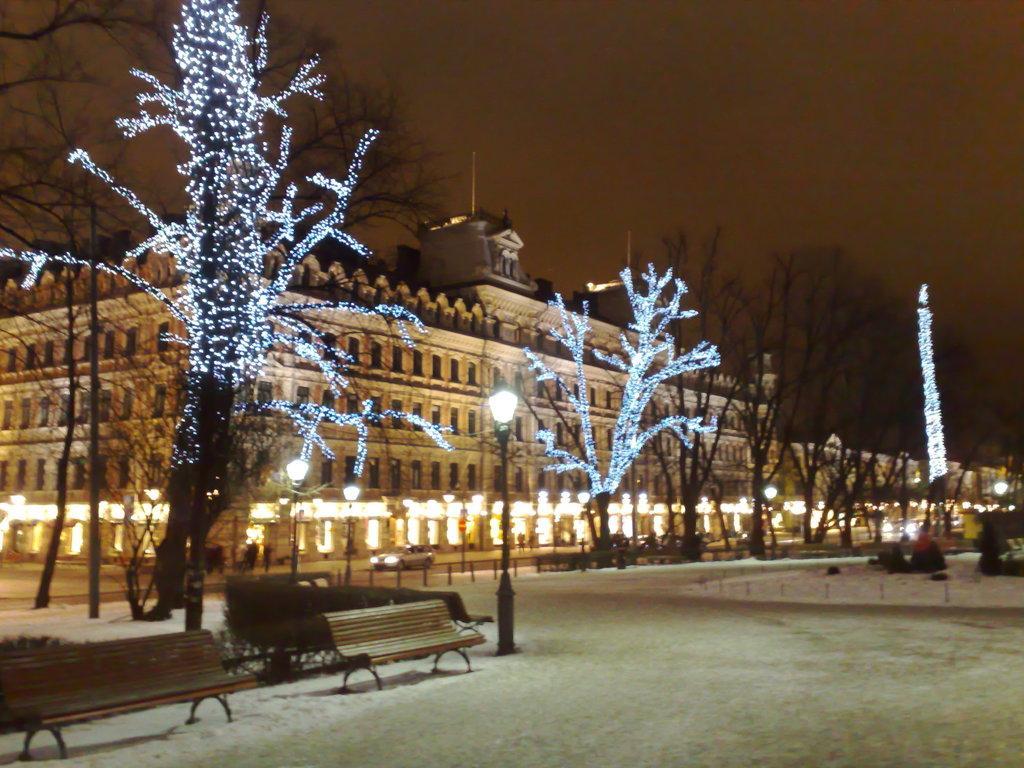Can you describe this image briefly? This picture is taken in night , in the middle I can see a building , in front of the building I can see a trees, on the trees i can see a lights , in front of the tree I can see a bench and street light pole and at the top I can see the sky. 